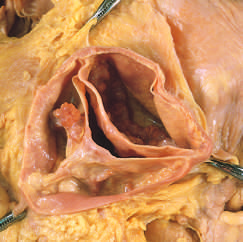does margin p have a partial fusion at its center?
Answer the question using a single word or phrase. No 